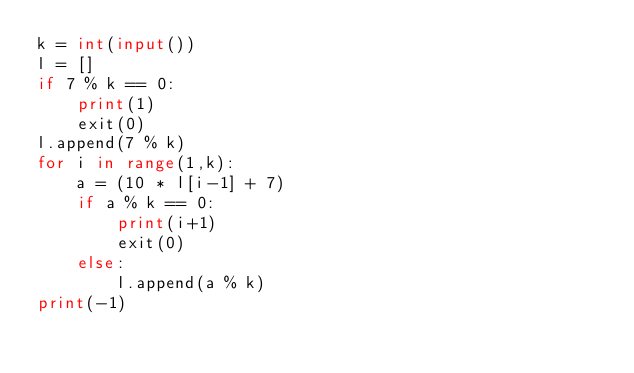Convert code to text. <code><loc_0><loc_0><loc_500><loc_500><_Python_>k = int(input())
l = []
if 7 % k == 0:
    print(1)
    exit(0)
l.append(7 % k)
for i in range(1,k):
    a = (10 * l[i-1] + 7)
    if a % k == 0:
        print(i+1)
        exit(0)
    else:
        l.append(a % k)
print(-1)    </code> 